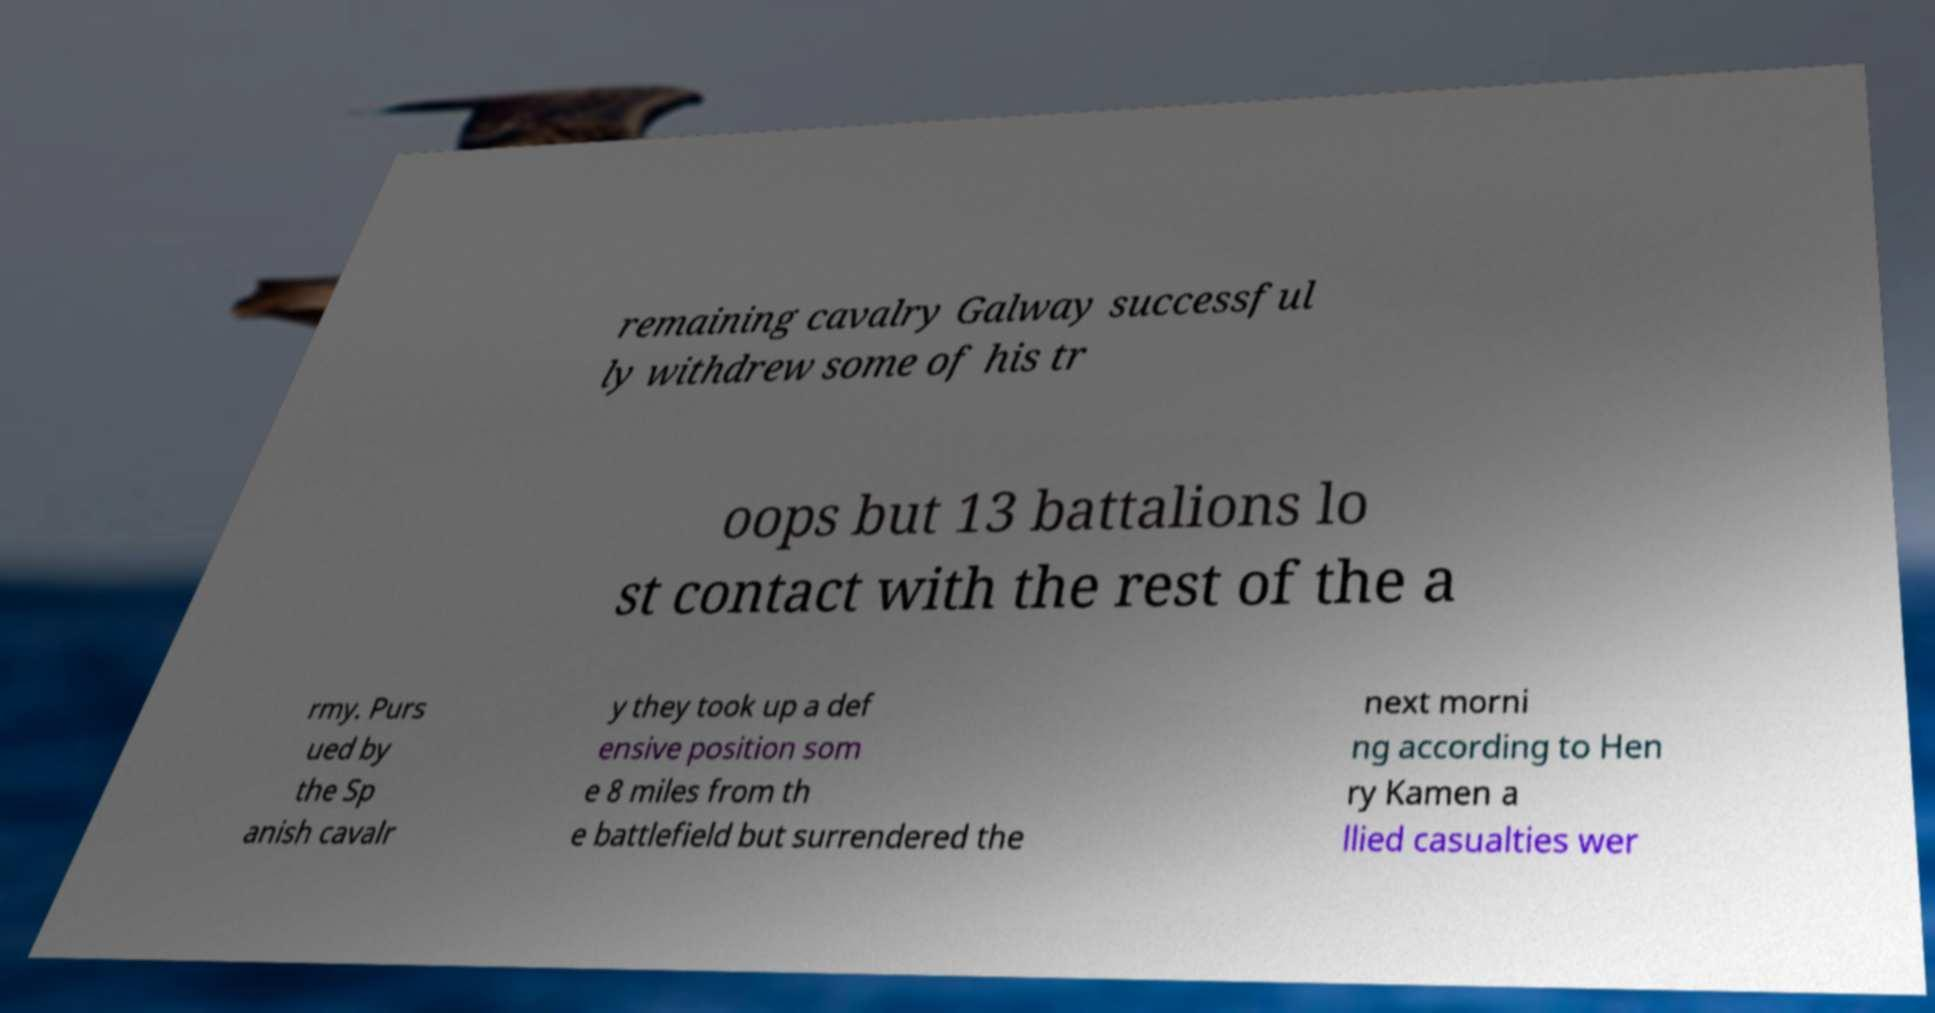Could you assist in decoding the text presented in this image and type it out clearly? remaining cavalry Galway successful ly withdrew some of his tr oops but 13 battalions lo st contact with the rest of the a rmy. Purs ued by the Sp anish cavalr y they took up a def ensive position som e 8 miles from th e battlefield but surrendered the next morni ng according to Hen ry Kamen a llied casualties wer 